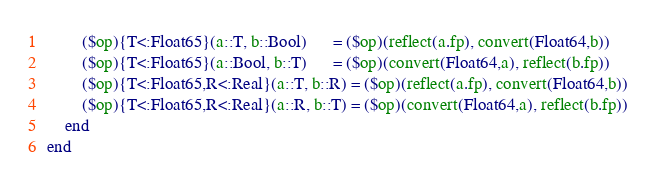<code> <loc_0><loc_0><loc_500><loc_500><_Julia_>        ($op){T<:Float65}(a::T, b::Bool)      = ($op)(reflect(a.fp), convert(Float64,b))
        ($op){T<:Float65}(a::Bool, b::T)      = ($op)(convert(Float64,a), reflect(b.fp))
        ($op){T<:Float65,R<:Real}(a::T, b::R) = ($op)(reflect(a.fp), convert(Float64,b))
        ($op){T<:Float65,R<:Real}(a::R, b::T) = ($op)(convert(Float64,a), reflect(b.fp))
    end
end

</code> 